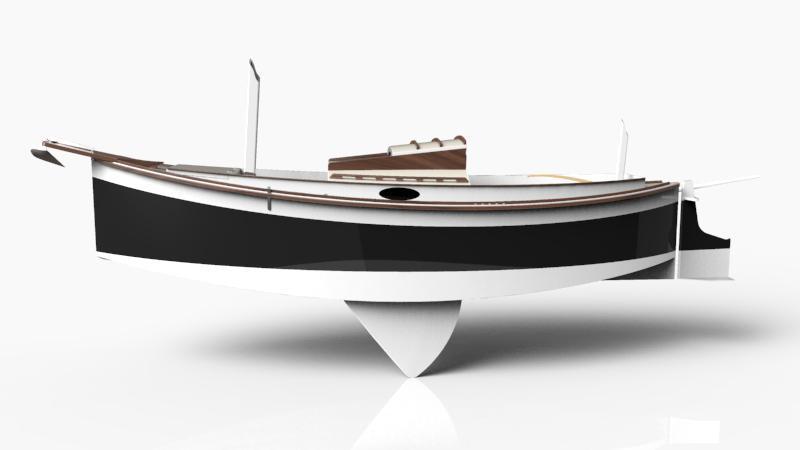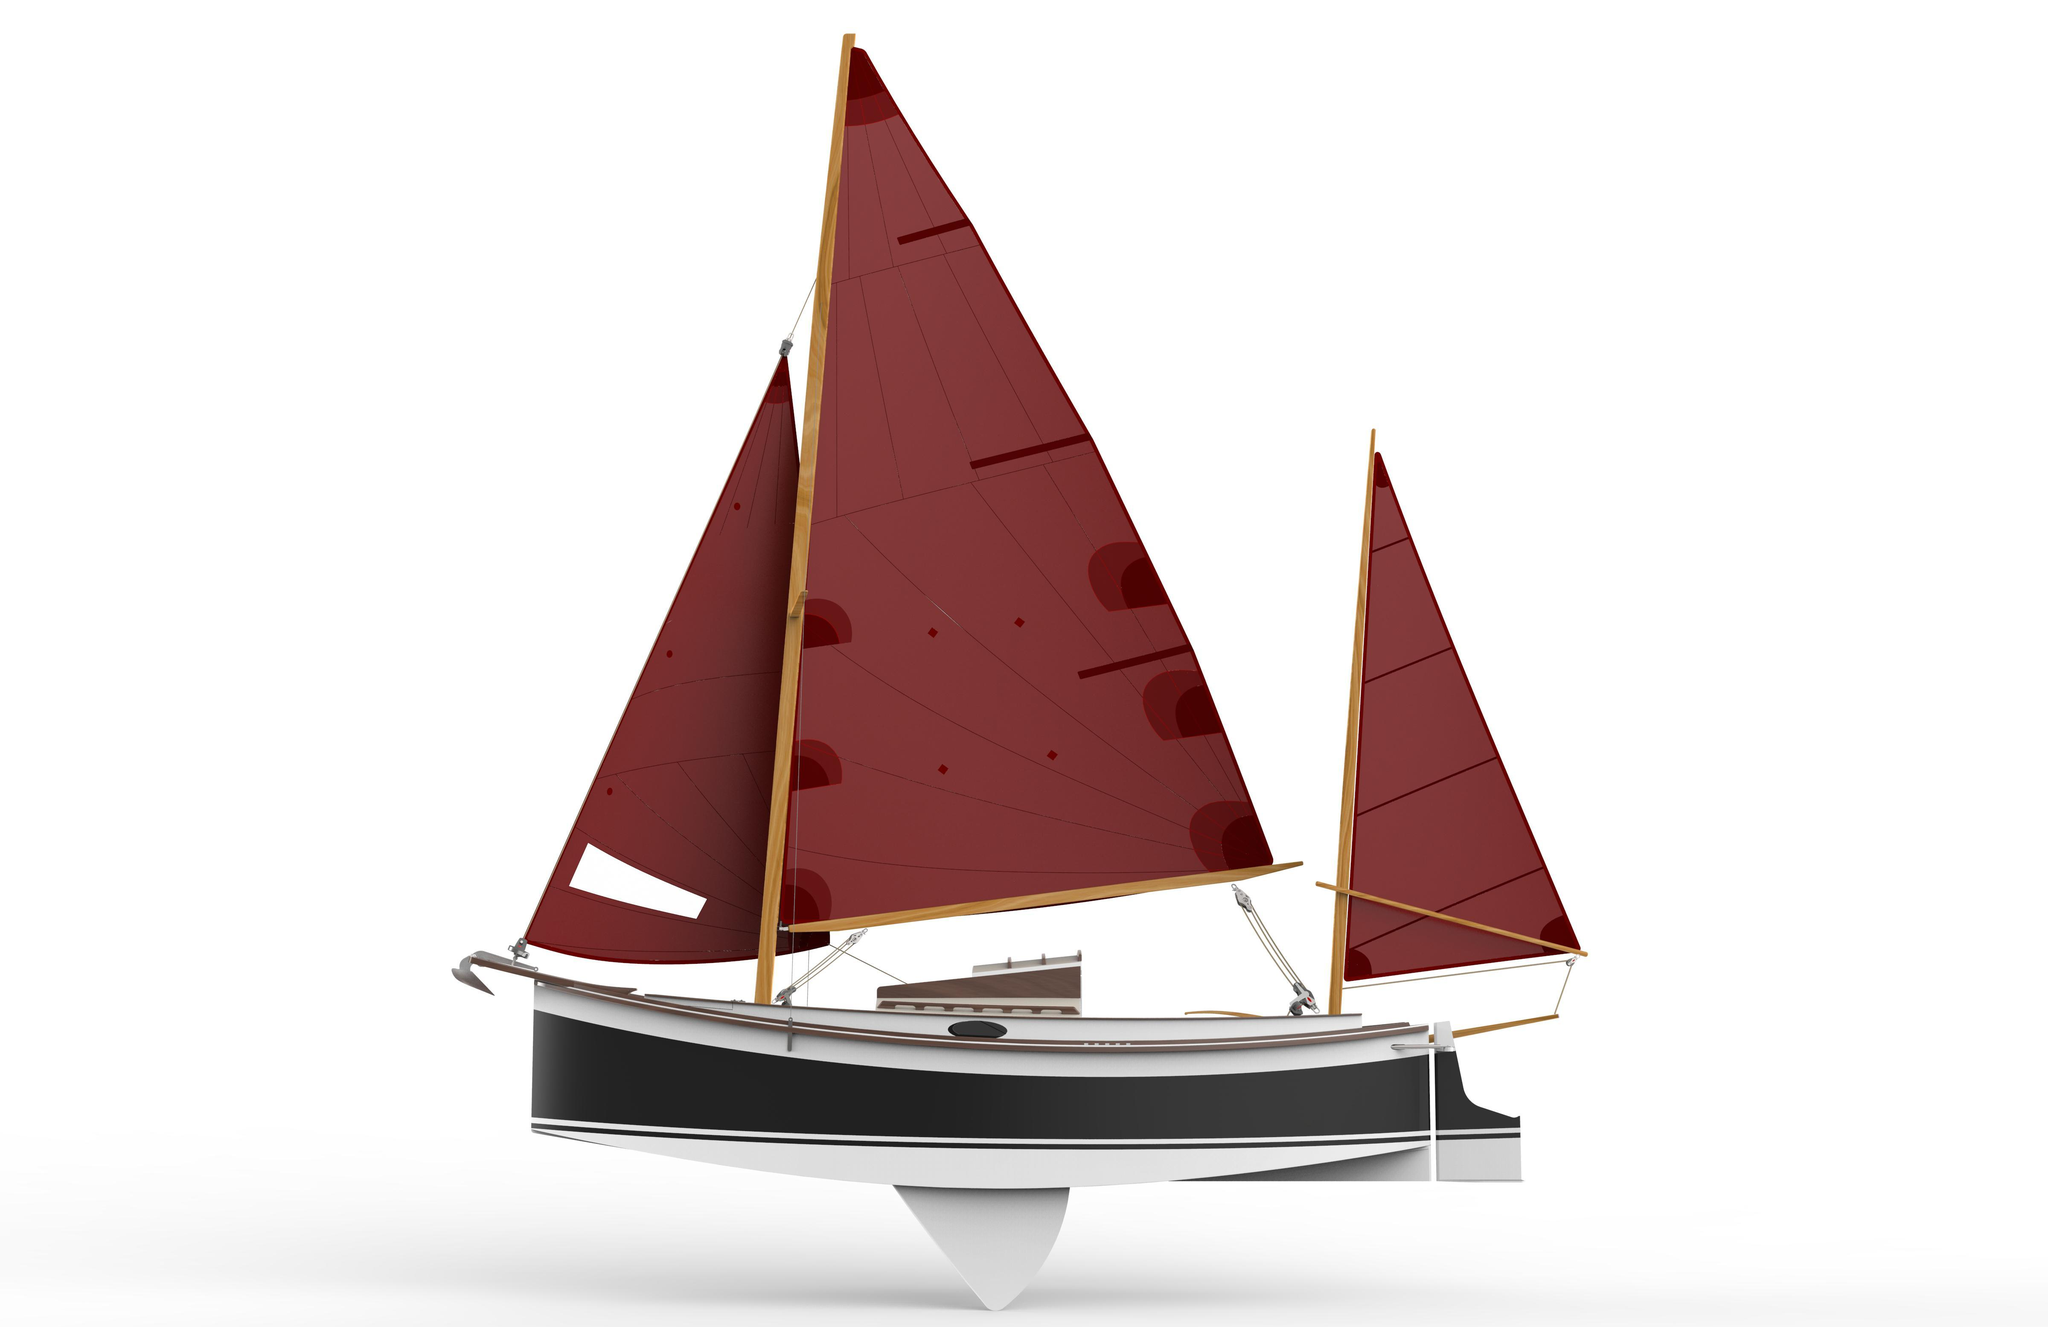The first image is the image on the left, the second image is the image on the right. Examine the images to the left and right. Is the description "The left and right images feature the same type of boat model, but the boat on the left has no upright dowel mast, and the boat on the right has an upright mast." accurate? Answer yes or no. Yes. The first image is the image on the left, the second image is the image on the right. Considering the images on both sides, is "Both boats have unfurled sails." valid? Answer yes or no. No. 